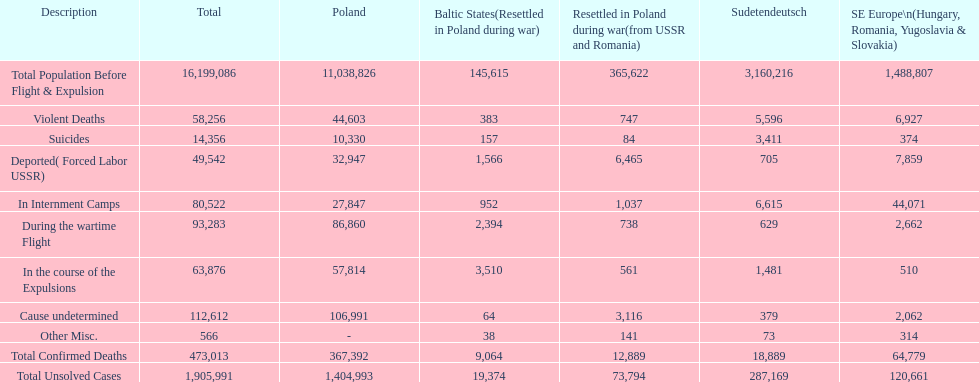What is the cumulative death toll in internment camps and amid the wartime flight? 173,805. 